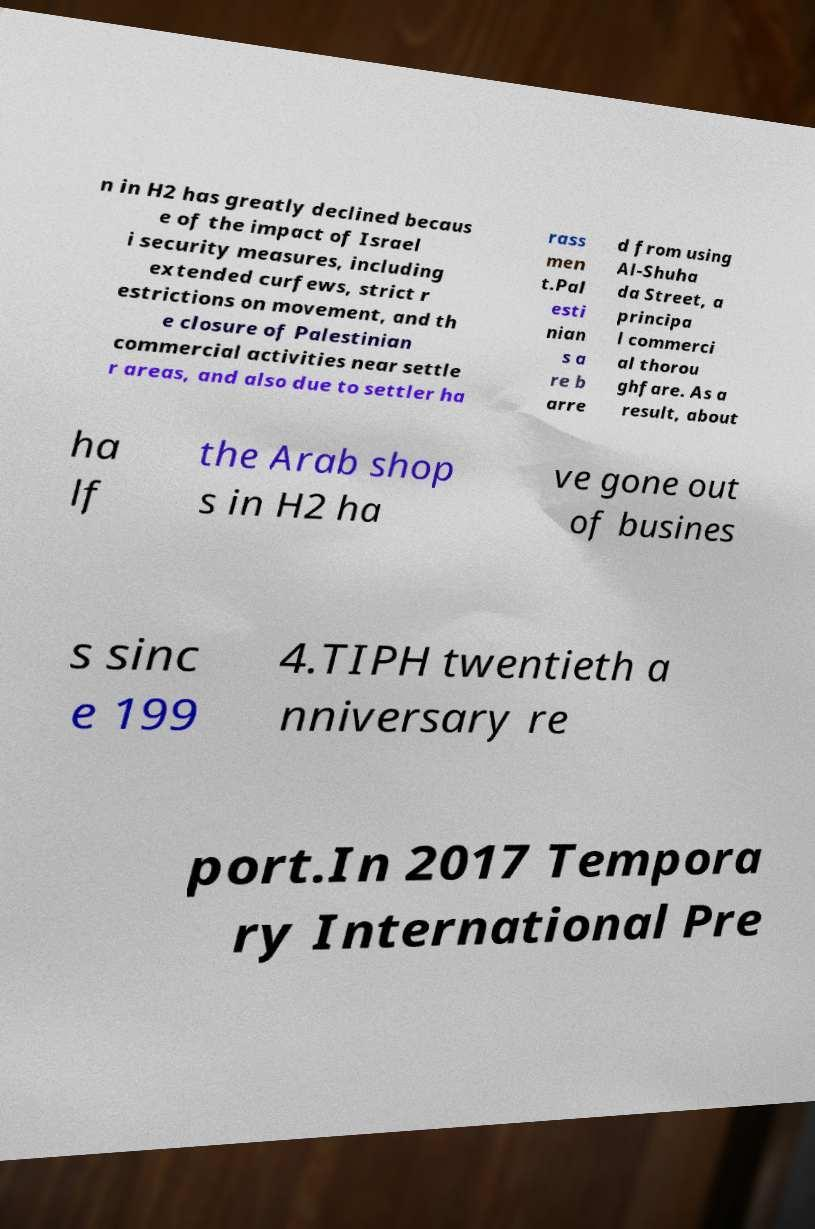Could you assist in decoding the text presented in this image and type it out clearly? n in H2 has greatly declined becaus e of the impact of Israel i security measures, including extended curfews, strict r estrictions on movement, and th e closure of Palestinian commercial activities near settle r areas, and also due to settler ha rass men t.Pal esti nian s a re b arre d from using Al-Shuha da Street, a principa l commerci al thorou ghfare. As a result, about ha lf the Arab shop s in H2 ha ve gone out of busines s sinc e 199 4.TIPH twentieth a nniversary re port.In 2017 Tempora ry International Pre 